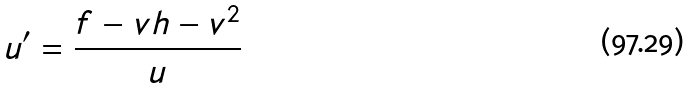<formula> <loc_0><loc_0><loc_500><loc_500>u ^ { \prime } = \frac { f - v h - v ^ { 2 } } { u }</formula> 